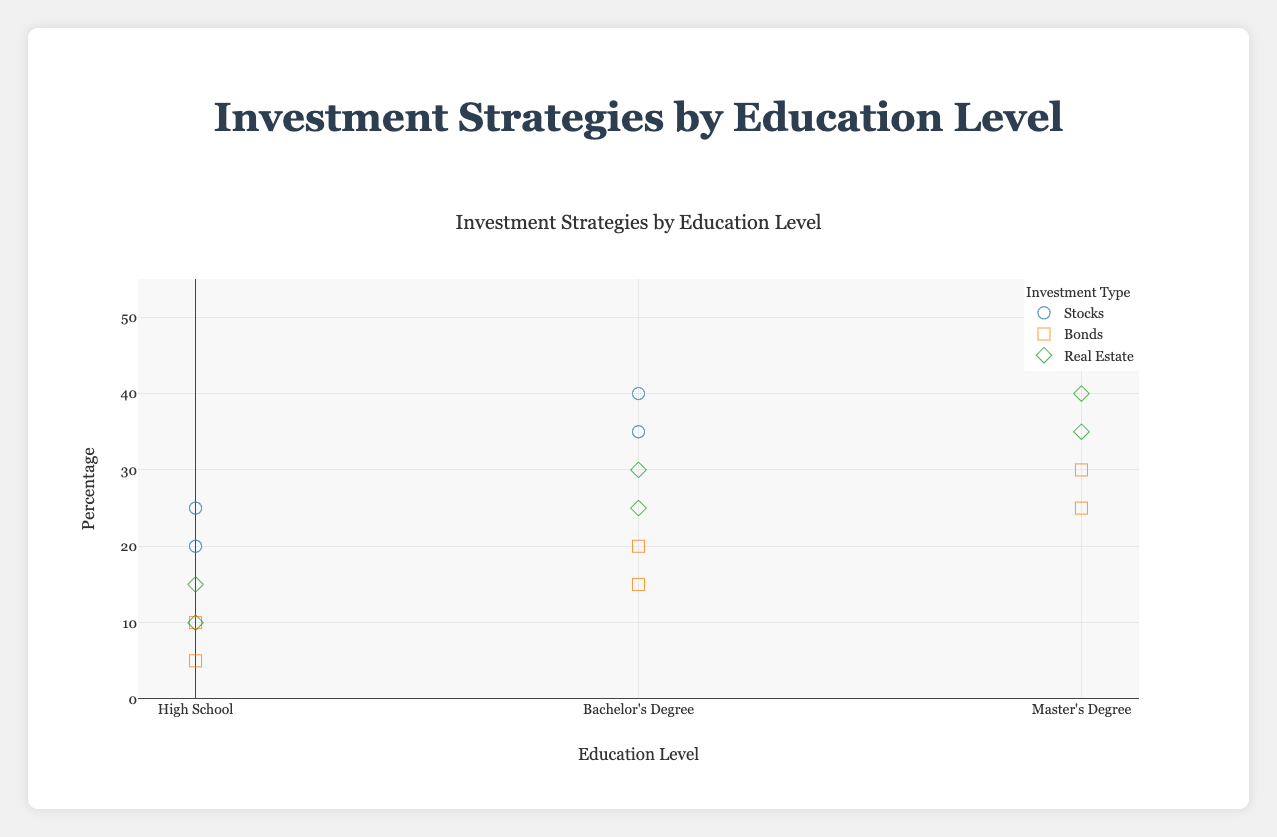What is the title of the plot? The title of the plot is displayed at the top and helps to understand what the figure is about. By looking at the top of the plot, the title is "Investment Strategies by Education Level".
Answer: Investment Strategies by Education Level What is the range of the y-axis? The y-axis indicates the percentage of retirees using different investment strategies. The range is shown on the left side of the plot, starting at 0% and ending at 55%.
Answer: 0 to 55 Which investment type is most popular among retirees with a Master's Degree in New York? To find the most popular investment type, look for the highest y-value (percentage) among the data points for those with a Master's Degree in New York. The highest percentage here is 50%, which corresponds to stocks.
Answer: Stocks How does the percentage of retirees with a High School education investing in Stocks differ between New York and Los Angeles? Compare the y-values for High School education and Stocks in both cities. In New York, it is 20%, and in Los Angeles, it is 25%. The difference is 25% - 20% = 5%.
Answer: 5% Which city shows the highest percentage of retirees investing in real estate with a Bachelor's Degree? For this question, filter out the investment type "Real Estate" and education level "Bachelor's Degree". Among the cities New York, Chicago, the highest y-value is in Chicago with 30%.
Answer: Chicago What is the average percentage of retirees with a Bachelor's Degree investing in Bonds across all cities? Select data points for "Bachelor's Degree" and "Bonds" across different cities. The percentages are 20% (New York) and 15% (Chicago). Average these by summing them up and dividing by the number of points: (20 + 15) / 2 = 17.5%.
Answer: 17.5% Which investment type is least favored by retirees with only a High School education in Los Angeles? Locate the data points for "High School" education in Los Angeles. Stocks (25%), Bonds (5%), and Real Estate (10%). The lowest percentage is for Bonds at 5%.
Answer: Bonds Is there any city where retirees with a Master's Degree invest equally in Bonds and Real Estate? Compare the y-values for Master's Degree holders investing in Bonds and Real Estate for each city. In Boston, the percentages for both Bonds and Real Estate are 25% and 35%, respectively. Therefore, no city shows equal investment in both for retirees with a Master’s Degree.
Answer: No What investment strategy do retirees with Bachelor's Degrees in New York prefer the least? Identify the y-values for each investment strategy for Bachelor's Degree holders in New York: Stocks (35%), Bonds (20%), Real Estate (25%). The lowest percentage here is for Bonds at 20%.
Answer: Bonds What is the combined percentage of retirees with a Master's Degree investing in Stocks and Real Estate in New York? Add the percentages of Stocks (50%) and Real Estate (40%) for Master's Degree holders in New York: 50 + 40 = 90%.
Answer: 90% 